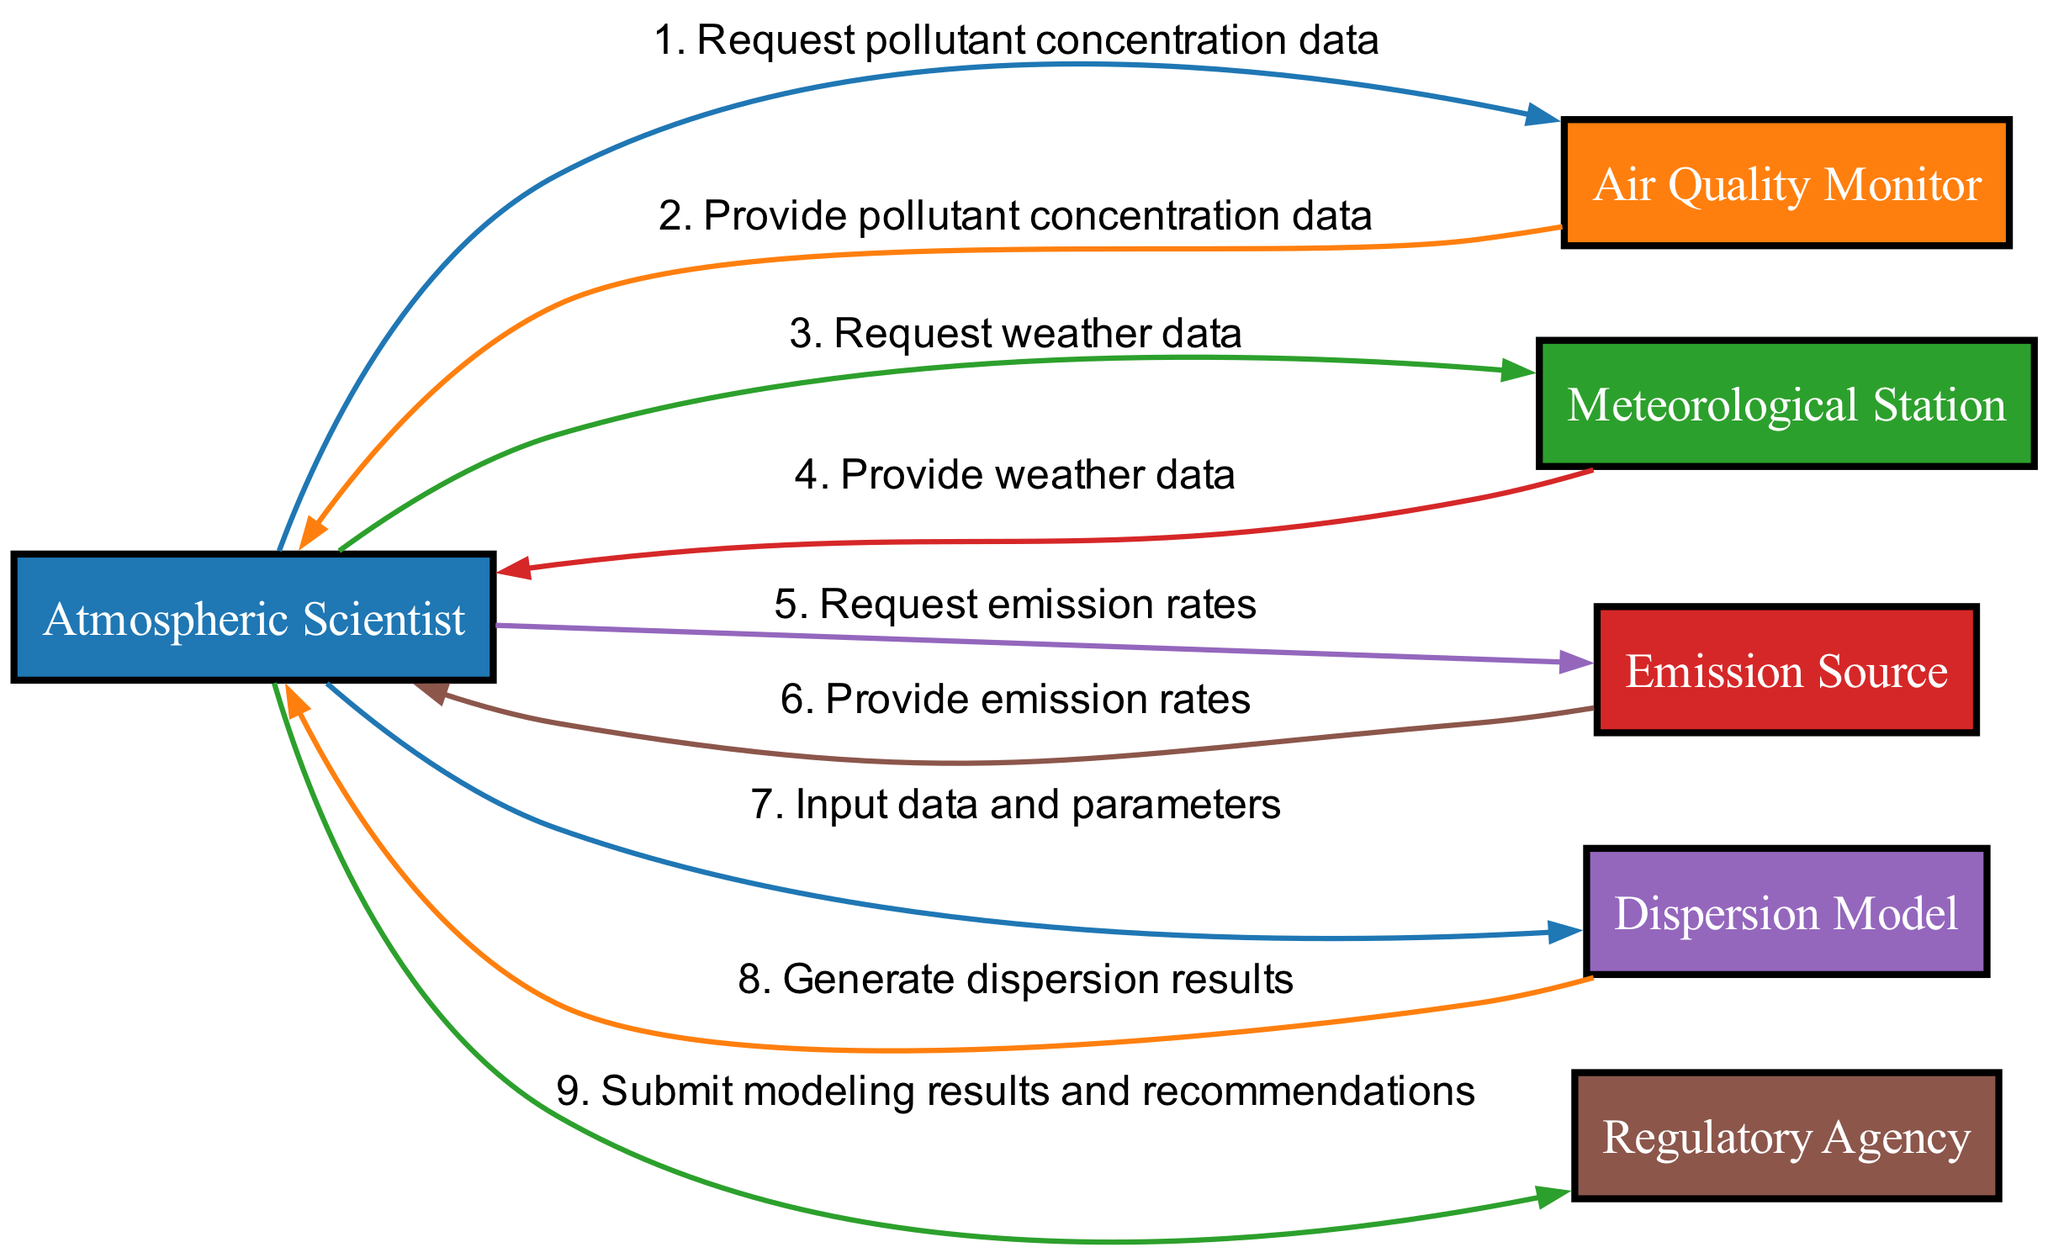What is the first request made by the Atmospheric Scientist? The first request in the sequence diagram is made by the Atmospheric Scientist to the Air Quality Monitor for pollutant concentration data. This is indicated as the first message from the Atmospheric Scientist in the sequence.
Answer: Request pollutant concentration data How many actors are involved in this workflow? The diagram lists six distinct actors involved in the workflow: Atmospheric Scientist, Air Quality Monitor, Meteorological Station, Emission Source, Dispersion Model, and Regulatory Agency. Therefore, the count is based on the unique actor nodes in the diagram.
Answer: Six Which actor provides weather data to the Atmospheric Scientist? The Meteorological Station provides the weather data, as indicated in the second request from the Atmospheric Scientist in the sequence diagram. It explicitly shows the flow of the message from the Meteorological Station to the Atmospheric Scientist.
Answer: Meteorological Station What message does the Emission Source send back to the Atmospheric Scientist? The Emission Source provides the emission rates back to the Atmospheric Scientist as the response to their request for emission rates. This is the sixth message in the sequence illustrated in the diagram.
Answer: Provide emission rates How many messages are sent from the Atmospheric Scientist to other actors? The Atmospheric Scientist sends a total of four messages to different actors: to the Air Quality Monitor, the Meteorological Station, the Emission Source, and the Dispersion Model. By analyzing the outgoing messages from the Atmospheric Scientist in the sequence, the total is calculated.
Answer: Four What is the final interaction in the sequence diagram? The final interaction involves the Atmospheric Scientist submitting the modeling results and recommendations to the Regulatory Agency, marking the end of the sequential flow. This is represented as the last message in the diagram, showcasing the completion of the workflow.
Answer: Submit modeling results and recommendations Which two actors are primarily responsible for providing data to the Atmospheric Scientist? The two actors that provide data to the Atmospheric Scientist are the Air Quality Monitor and the Meteorological Station, supplying the required pollutant concentration data and weather data, respectively. These interactions are identified as the second and fourth messages sent in the sequence.
Answer: Air Quality Monitor, Meteorological Station 